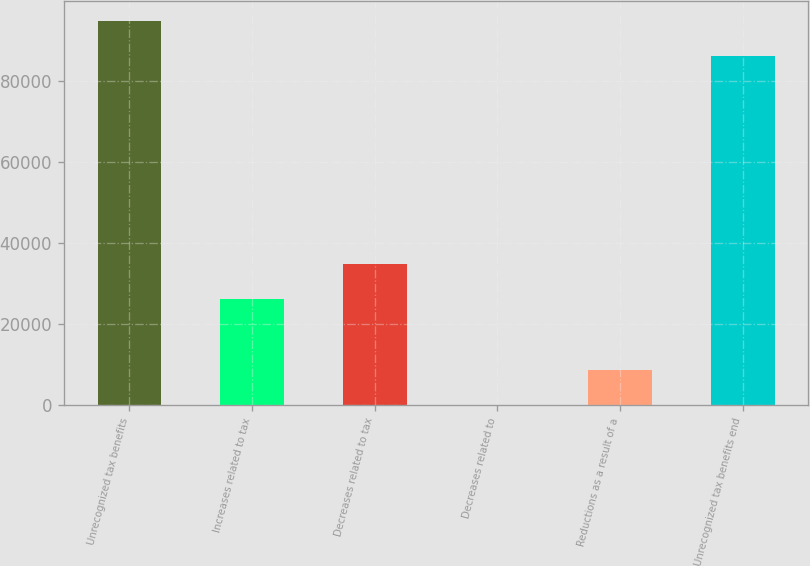Convert chart to OTSL. <chart><loc_0><loc_0><loc_500><loc_500><bar_chart><fcel>Unrecognized tax benefits<fcel>Increases related to tax<fcel>Decreases related to tax<fcel>Decreases related to<fcel>Reductions as a result of a<fcel>Unrecognized tax benefits end<nl><fcel>94861.1<fcel>26098.3<fcel>34750.4<fcel>142<fcel>8794.1<fcel>86209<nl></chart> 